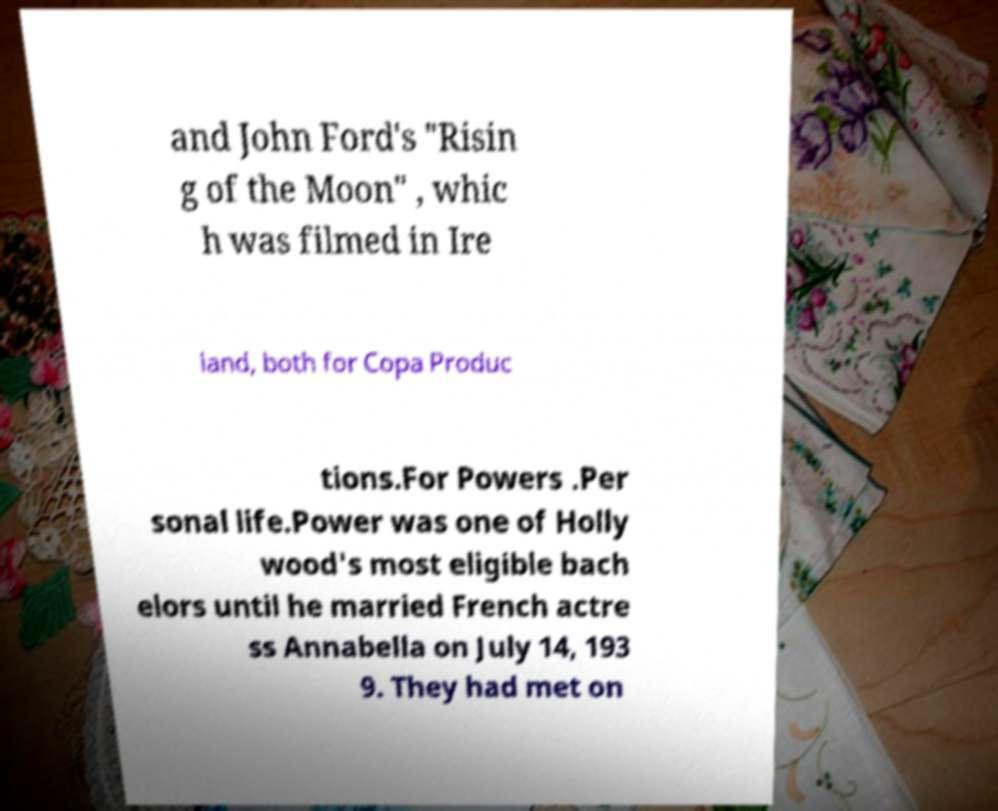There's text embedded in this image that I need extracted. Can you transcribe it verbatim? and John Ford's "Risin g of the Moon" , whic h was filmed in Ire land, both for Copa Produc tions.For Powers .Per sonal life.Power was one of Holly wood's most eligible bach elors until he married French actre ss Annabella on July 14, 193 9. They had met on 